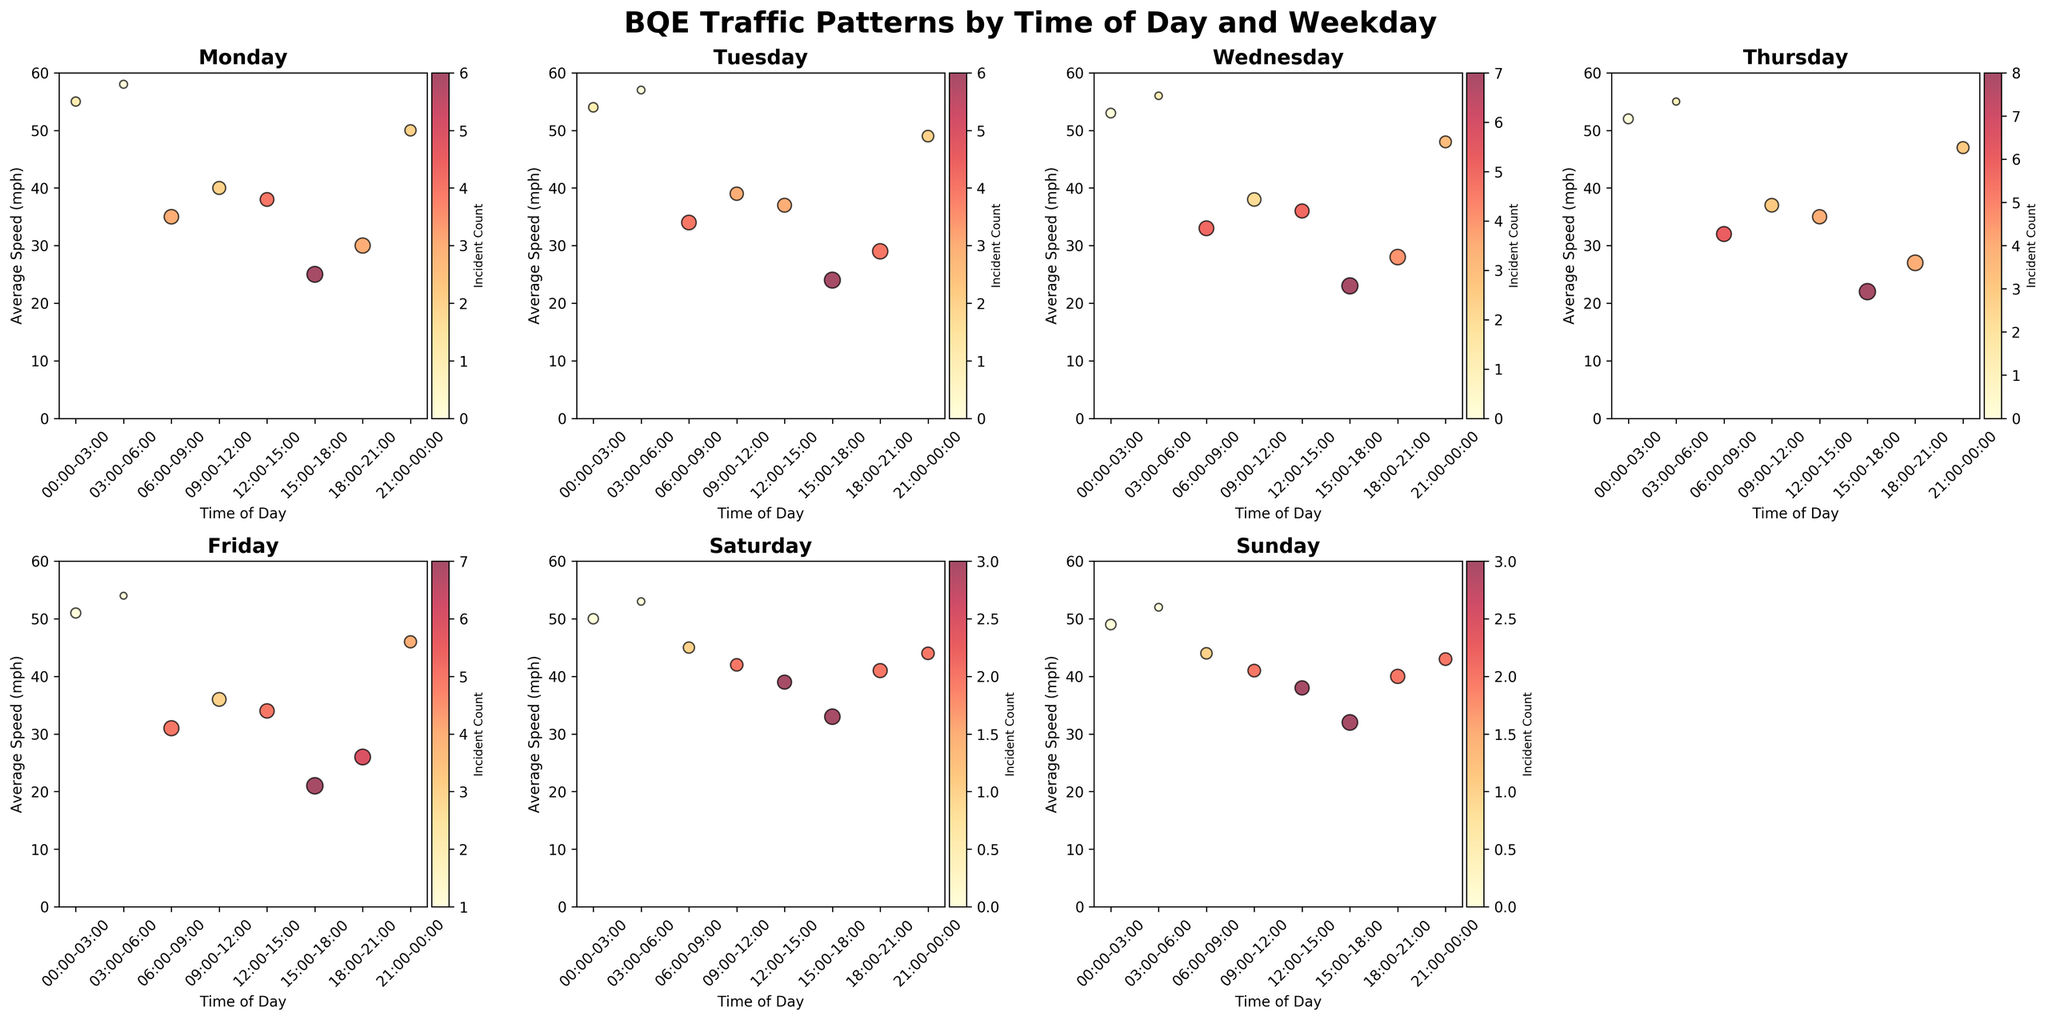What is the title of the entire figure? The title is displayed at the top of the figure in bold letters: "BQE Traffic Patterns by Time of Day and Weekday".
Answer: BQE Traffic Patterns by Time of Day and Weekday How does traffic volume appear visually on the chart? In the bubble chart, the size of each bubble represents the traffic volume; larger bubbles indicate higher traffic volumes, while smaller bubbles indicate lower traffic volumes.
Answer: Bubble size Which day has the highest number of incidents recorded during 15:00-18:00? Comparing the color bar across the days for the 15:00-18:00 time slot, we find that Thursday's bubble has the highest count of 8 incidents.
Answer: Thursday Which day and time combination has the lowest average speed? By checking the y-axes of each subplot, the lowest average speed occurs during 15:00-18:00 on Thursday, with an average speed of 22 mph.
Answer: Thursday 15:00-18:00 Which weekday has the most traffic volume during 06:00-09:00? Looking at the size of the bubbles during the 06:00-09:00 time period across the days, Friday has the largest bubble indicating the highest traffic volume.
Answer: Friday How does the incident count change from Monday 06:00-09:00 to Friday 06:00-09:00? The incident count for Monday is 3 and for Friday is 5. The change is calculated as 5 (Friday) - 3 (Monday) = 2, showing an increase of 2 incidents.
Answer: Increase by 2 What is the highest average speed recorded on any day and time, and during which period? The highest average speed is 58 mph, recorded during 03:00-06:00 on Monday.
Answer: 58 mph on Monday 03:00-06:00 Are there any times with zero incident counts? Checking the color bar, bubbles with zero incident counts are pale yellow. These times include early morning periods like Monday 03:00-06:00.
Answer: Yes, e.g., Monday 03:00-06:00 How does the average speed on Sunday during 18:00-21:00 compare to Saturday during the same time? By comparing the positions on the y-axis, Sunday has an average speed of 40 mph while Saturday has 41 mph.
Answer: Sunday is 1 mph lower than Saturday 